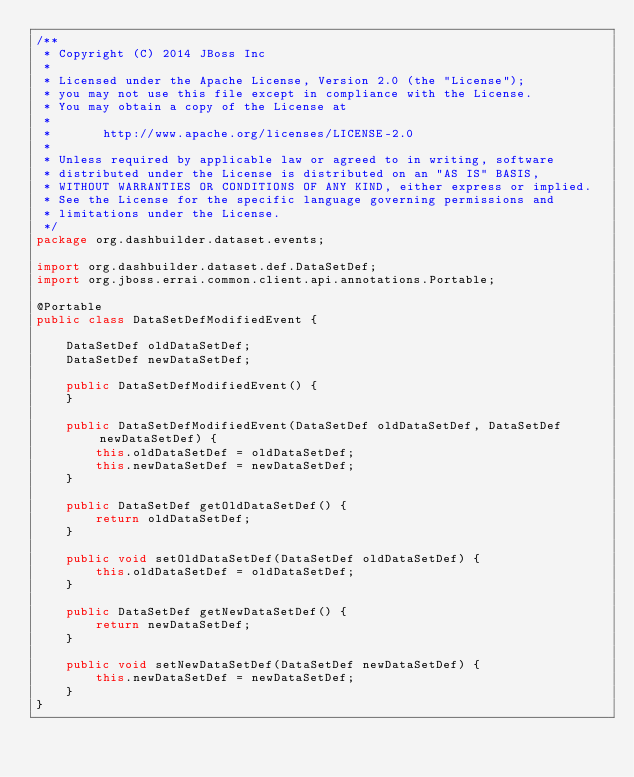Convert code to text. <code><loc_0><loc_0><loc_500><loc_500><_Java_>/**
 * Copyright (C) 2014 JBoss Inc
 *
 * Licensed under the Apache License, Version 2.0 (the "License");
 * you may not use this file except in compliance with the License.
 * You may obtain a copy of the License at
 *
 *       http://www.apache.org/licenses/LICENSE-2.0
 *
 * Unless required by applicable law or agreed to in writing, software
 * distributed under the License is distributed on an "AS IS" BASIS,
 * WITHOUT WARRANTIES OR CONDITIONS OF ANY KIND, either express or implied.
 * See the License for the specific language governing permissions and
 * limitations under the License.
 */
package org.dashbuilder.dataset.events;

import org.dashbuilder.dataset.def.DataSetDef;
import org.jboss.errai.common.client.api.annotations.Portable;

@Portable
public class DataSetDefModifiedEvent {

    DataSetDef oldDataSetDef;
    DataSetDef newDataSetDef;

    public DataSetDefModifiedEvent() {
    }

    public DataSetDefModifiedEvent(DataSetDef oldDataSetDef, DataSetDef newDataSetDef) {
        this.oldDataSetDef = oldDataSetDef;
        this.newDataSetDef = newDataSetDef;
    }

    public DataSetDef getOldDataSetDef() {
        return oldDataSetDef;
    }

    public void setOldDataSetDef(DataSetDef oldDataSetDef) {
        this.oldDataSetDef = oldDataSetDef;
    }

    public DataSetDef getNewDataSetDef() {
        return newDataSetDef;
    }

    public void setNewDataSetDef(DataSetDef newDataSetDef) {
        this.newDataSetDef = newDataSetDef;
    }
}
</code> 